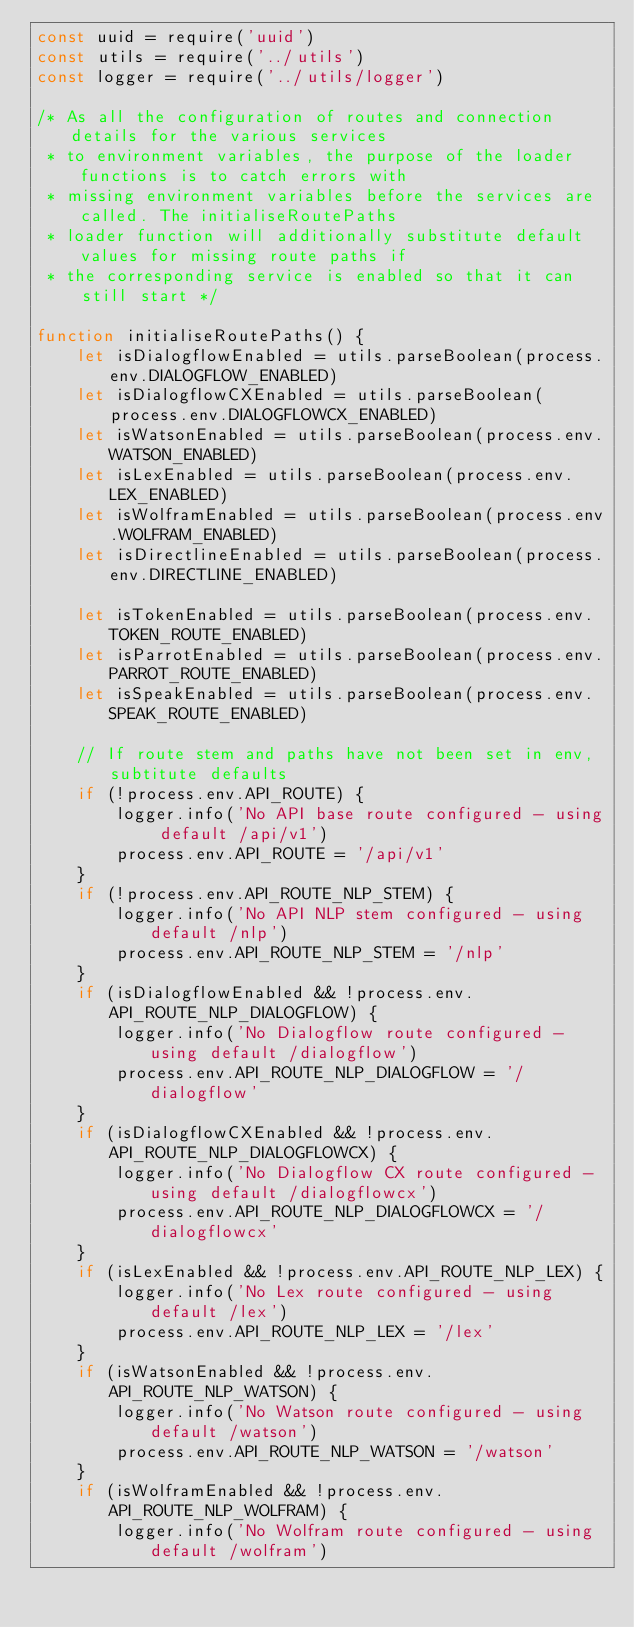Convert code to text. <code><loc_0><loc_0><loc_500><loc_500><_JavaScript_>const uuid = require('uuid')
const utils = require('../utils')
const logger = require('../utils/logger')

/* As all the configuration of routes and connection details for the various services
 * to environment variables, the purpose of the loader functions is to catch errors with
 * missing environment variables before the services are called. The initialiseRoutePaths
 * loader function will additionally substitute default values for missing route paths if
 * the corresponding service is enabled so that it can still start */

function initialiseRoutePaths() {
    let isDialogflowEnabled = utils.parseBoolean(process.env.DIALOGFLOW_ENABLED)
    let isDialogflowCXEnabled = utils.parseBoolean(process.env.DIALOGFLOWCX_ENABLED)
    let isWatsonEnabled = utils.parseBoolean(process.env.WATSON_ENABLED)
    let isLexEnabled = utils.parseBoolean(process.env.LEX_ENABLED)
    let isWolframEnabled = utils.parseBoolean(process.env.WOLFRAM_ENABLED)
    let isDirectlineEnabled = utils.parseBoolean(process.env.DIRECTLINE_ENABLED)

    let isTokenEnabled = utils.parseBoolean(process.env.TOKEN_ROUTE_ENABLED)
    let isParrotEnabled = utils.parseBoolean(process.env.PARROT_ROUTE_ENABLED)
    let isSpeakEnabled = utils.parseBoolean(process.env.SPEAK_ROUTE_ENABLED)

    // If route stem and paths have not been set in env, subtitute defaults
    if (!process.env.API_ROUTE) {
        logger.info('No API base route configured - using default /api/v1')
        process.env.API_ROUTE = '/api/v1'
    }
    if (!process.env.API_ROUTE_NLP_STEM) {
        logger.info('No API NLP stem configured - using default /nlp')
        process.env.API_ROUTE_NLP_STEM = '/nlp'
    }
    if (isDialogflowEnabled && !process.env.API_ROUTE_NLP_DIALOGFLOW) {
        logger.info('No Dialogflow route configured - using default /dialogflow')
        process.env.API_ROUTE_NLP_DIALOGFLOW = '/dialogflow'
    }
    if (isDialogflowCXEnabled && !process.env.API_ROUTE_NLP_DIALOGFLOWCX) {
        logger.info('No Dialogflow CX route configured - using default /dialogflowcx')
        process.env.API_ROUTE_NLP_DIALOGFLOWCX = '/dialogflowcx'
    }
    if (isLexEnabled && !process.env.API_ROUTE_NLP_LEX) {
        logger.info('No Lex route configured - using default /lex')
        process.env.API_ROUTE_NLP_LEX = '/lex'
    }
    if (isWatsonEnabled && !process.env.API_ROUTE_NLP_WATSON) {
        logger.info('No Watson route configured - using default /watson')
        process.env.API_ROUTE_NLP_WATSON = '/watson'
    }
    if (isWolframEnabled && !process.env.API_ROUTE_NLP_WOLFRAM) {
        logger.info('No Wolfram route configured - using default /wolfram')</code> 